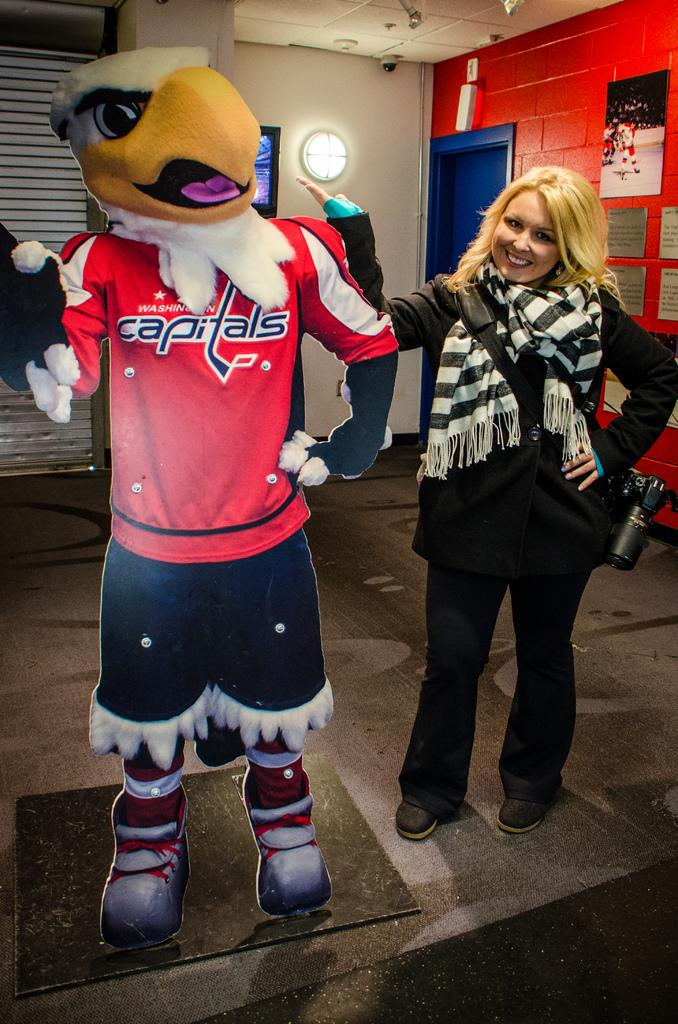<image>
Present a compact description of the photo's key features. Women standing next to a cut out of a mascot for the Washington Capitals. 